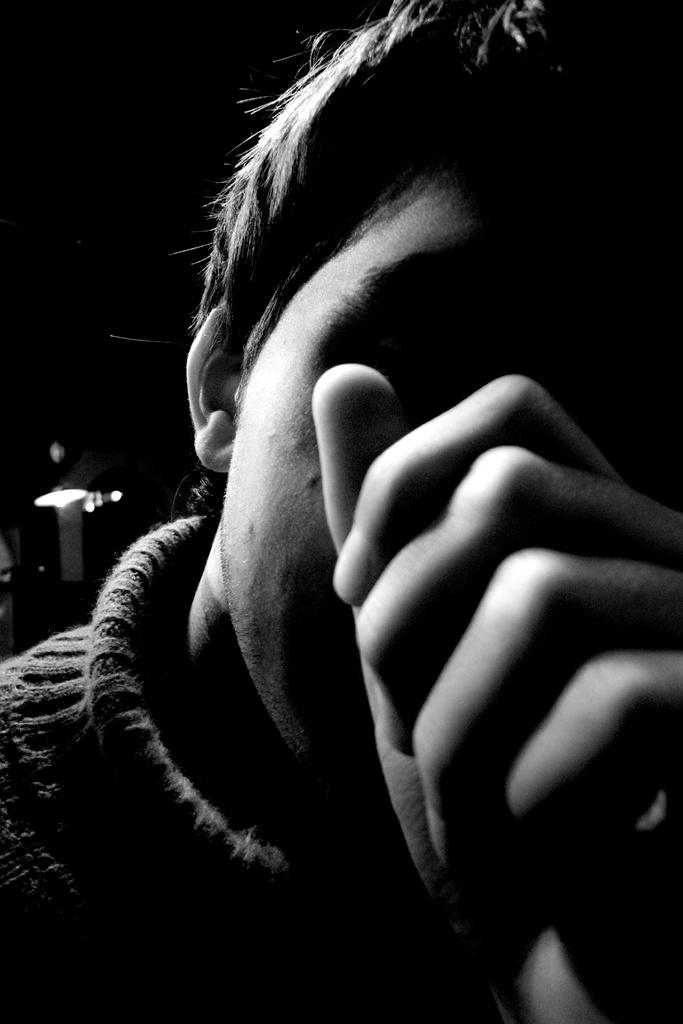What is the color scheme of the image? The image is black and white. Can you describe the person in the front of the image? There is a person in the front of the image wearing a sweatshirt. What can be seen in the background of the image? There is a light over the ceiling in the background of the image. What type of slope is visible in the image? There is no slope present in the image; it is a black and white image featuring a person and a light over the ceiling. Can you tell me the political affiliation of the governor in the image? There is no governor present in the image; it features a person wearing a sweatshirt and a light over the ceiling. 